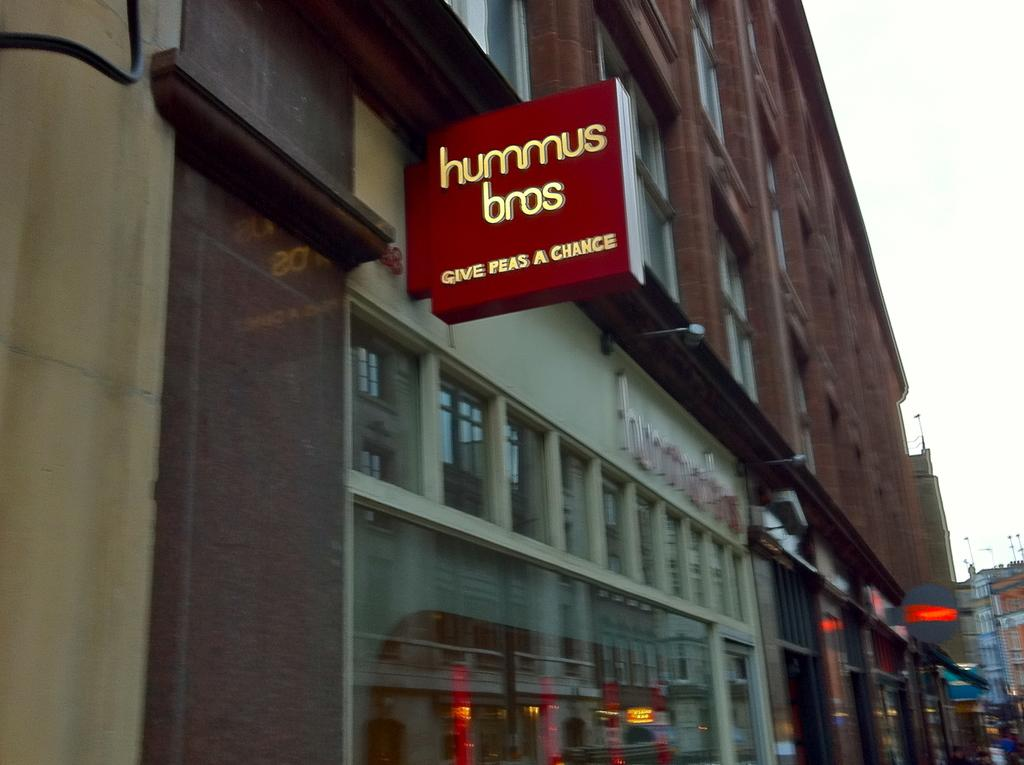What type of structures are present in the image? There are buildings in the image. What feature do the buildings have? The buildings have glass windows. Is there any additional information about one of the buildings? Yes, there is a board attached to one of the buildings. What type of lead can be seen connecting the buildings in the image? There is no lead connecting the buildings in the image; the buildings are separate structures. 